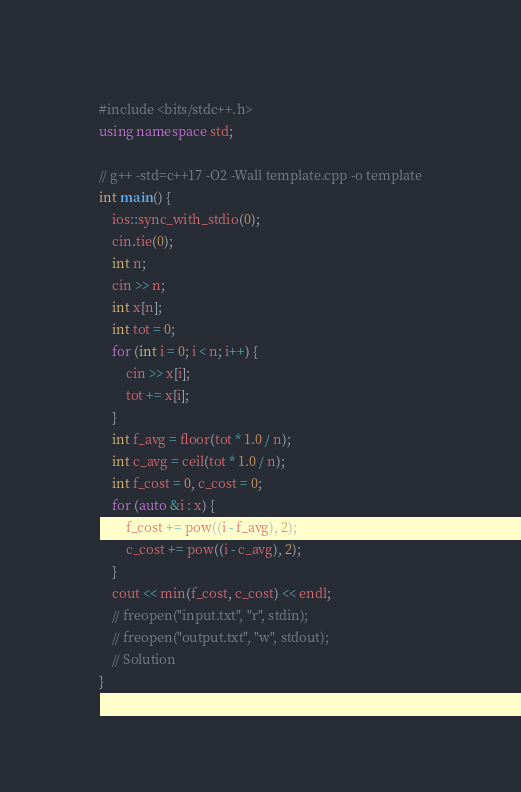Convert code to text. <code><loc_0><loc_0><loc_500><loc_500><_C++_>#include <bits/stdc++.h>
using namespace std;

// g++ -std=c++17 -O2 -Wall template.cpp -o template
int main() {
    ios::sync_with_stdio(0);
    cin.tie(0);
    int n;
    cin >> n;
    int x[n];
    int tot = 0;
    for (int i = 0; i < n; i++) {
        cin >> x[i];
        tot += x[i];
    }
    int f_avg = floor(tot * 1.0 / n);
    int c_avg = ceil(tot * 1.0 / n);
    int f_cost = 0, c_cost = 0;
    for (auto &i : x) {
        f_cost += pow((i - f_avg), 2);
        c_cost += pow((i - c_avg), 2);
    }
    cout << min(f_cost, c_cost) << endl;
    // freopen("input.txt", "r", stdin);
    // freopen("output.txt", "w", stdout);
    // Solution
}
</code> 